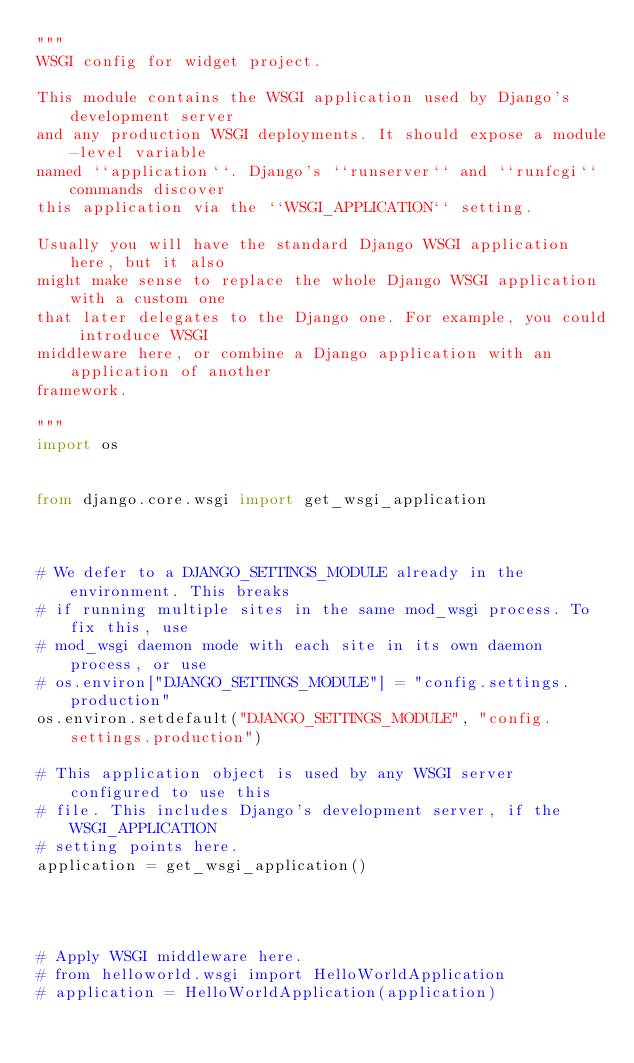Convert code to text. <code><loc_0><loc_0><loc_500><loc_500><_Python_>"""
WSGI config for widget project.

This module contains the WSGI application used by Django's development server
and any production WSGI deployments. It should expose a module-level variable
named ``application``. Django's ``runserver`` and ``runfcgi`` commands discover
this application via the ``WSGI_APPLICATION`` setting.

Usually you will have the standard Django WSGI application here, but it also
might make sense to replace the whole Django WSGI application with a custom one
that later delegates to the Django one. For example, you could introduce WSGI
middleware here, or combine a Django application with an application of another
framework.

"""
import os


from django.core.wsgi import get_wsgi_application



# We defer to a DJANGO_SETTINGS_MODULE already in the environment. This breaks
# if running multiple sites in the same mod_wsgi process. To fix this, use
# mod_wsgi daemon mode with each site in its own daemon process, or use
# os.environ["DJANGO_SETTINGS_MODULE"] = "config.settings.production"
os.environ.setdefault("DJANGO_SETTINGS_MODULE", "config.settings.production")

# This application object is used by any WSGI server configured to use this
# file. This includes Django's development server, if the WSGI_APPLICATION
# setting points here.
application = get_wsgi_application()




# Apply WSGI middleware here.
# from helloworld.wsgi import HelloWorldApplication
# application = HelloWorldApplication(application)
</code> 